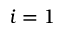<formula> <loc_0><loc_0><loc_500><loc_500>i = 1</formula> 